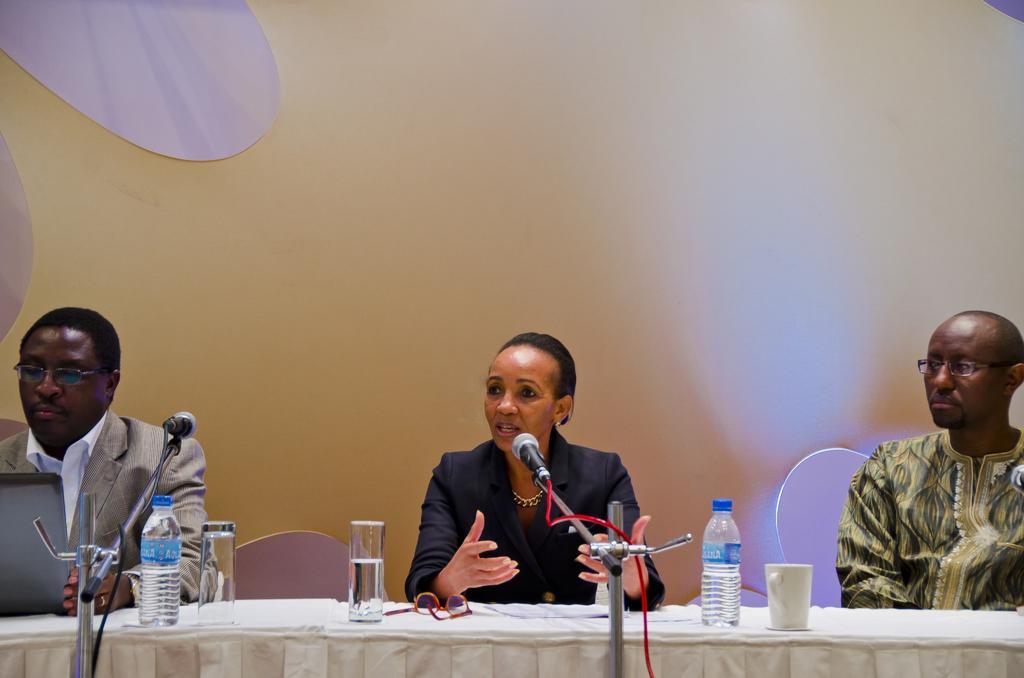Describe this image in one or two sentences. In this picture we can see three persons and in middle woman talking on mic and beside to her two persons listening to her, in front of them we have table and on table we can see bottle, glass, cup, mic and in background we can see wall. 